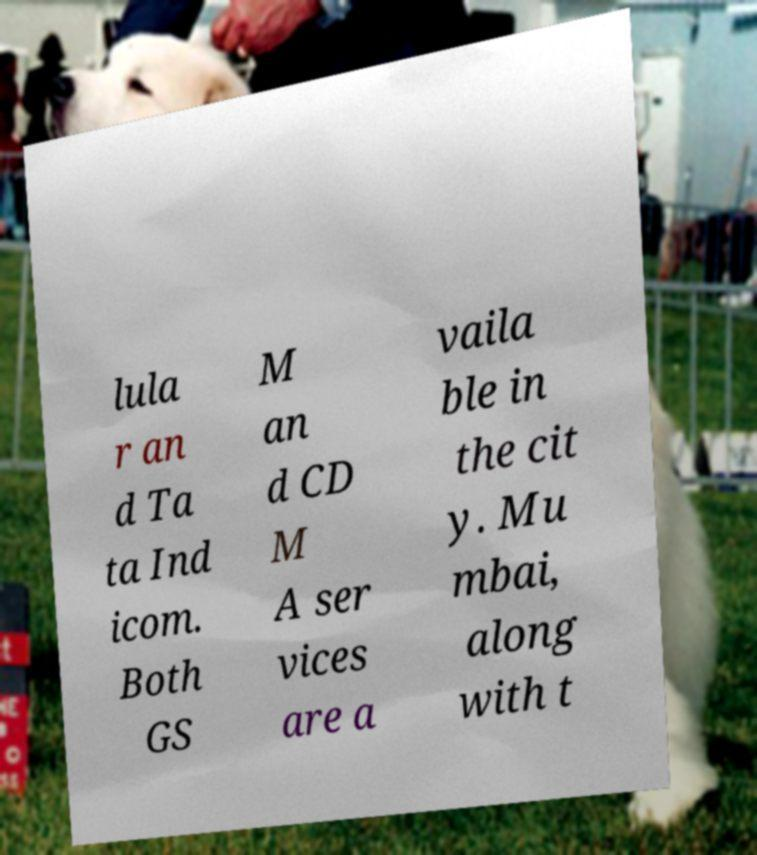Please identify and transcribe the text found in this image. lula r an d Ta ta Ind icom. Both GS M an d CD M A ser vices are a vaila ble in the cit y. Mu mbai, along with t 